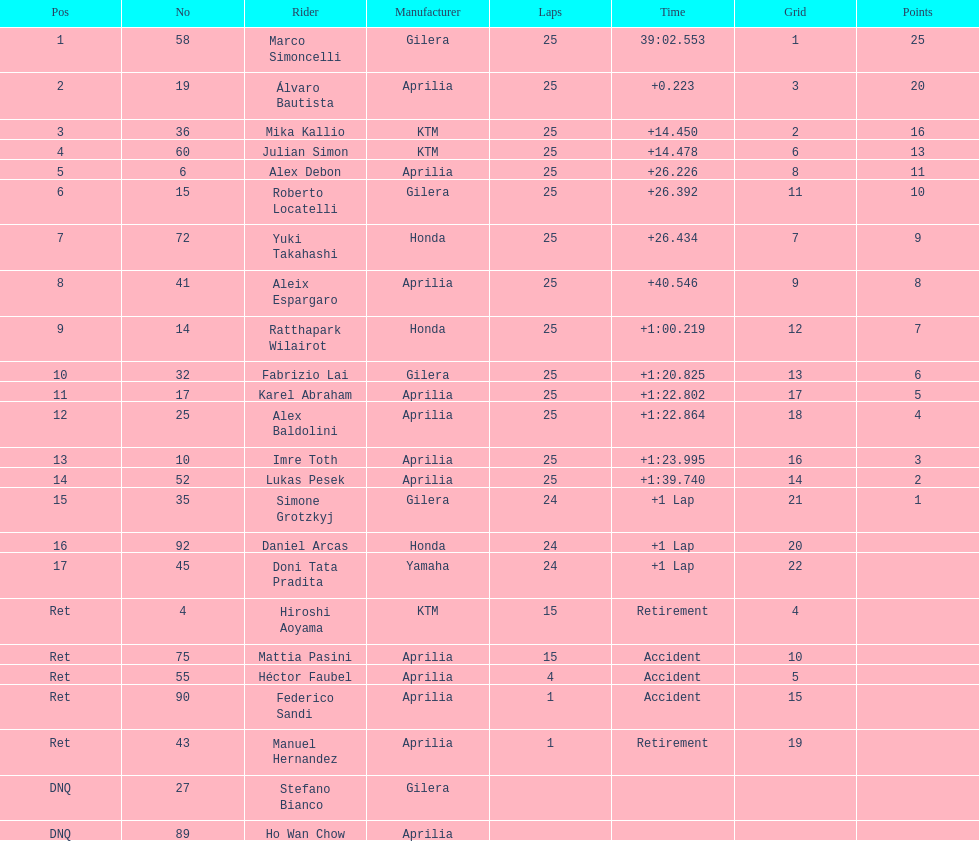Could you parse the entire table? {'header': ['Pos', 'No', 'Rider', 'Manufacturer', 'Laps', 'Time', 'Grid', 'Points'], 'rows': [['1', '58', 'Marco Simoncelli', 'Gilera', '25', '39:02.553', '1', '25'], ['2', '19', 'Álvaro Bautista', 'Aprilia', '25', '+0.223', '3', '20'], ['3', '36', 'Mika Kallio', 'KTM', '25', '+14.450', '2', '16'], ['4', '60', 'Julian Simon', 'KTM', '25', '+14.478', '6', '13'], ['5', '6', 'Alex Debon', 'Aprilia', '25', '+26.226', '8', '11'], ['6', '15', 'Roberto Locatelli', 'Gilera', '25', '+26.392', '11', '10'], ['7', '72', 'Yuki Takahashi', 'Honda', '25', '+26.434', '7', '9'], ['8', '41', 'Aleix Espargaro', 'Aprilia', '25', '+40.546', '9', '8'], ['9', '14', 'Ratthapark Wilairot', 'Honda', '25', '+1:00.219', '12', '7'], ['10', '32', 'Fabrizio Lai', 'Gilera', '25', '+1:20.825', '13', '6'], ['11', '17', 'Karel Abraham', 'Aprilia', '25', '+1:22.802', '17', '5'], ['12', '25', 'Alex Baldolini', 'Aprilia', '25', '+1:22.864', '18', '4'], ['13', '10', 'Imre Toth', 'Aprilia', '25', '+1:23.995', '16', '3'], ['14', '52', 'Lukas Pesek', 'Aprilia', '25', '+1:39.740', '14', '2'], ['15', '35', 'Simone Grotzkyj', 'Gilera', '24', '+1 Lap', '21', '1'], ['16', '92', 'Daniel Arcas', 'Honda', '24', '+1 Lap', '20', ''], ['17', '45', 'Doni Tata Pradita', 'Yamaha', '24', '+1 Lap', '22', ''], ['Ret', '4', 'Hiroshi Aoyama', 'KTM', '15', 'Retirement', '4', ''], ['Ret', '75', 'Mattia Pasini', 'Aprilia', '15', 'Accident', '10', ''], ['Ret', '55', 'Héctor Faubel', 'Aprilia', '4', 'Accident', '5', ''], ['Ret', '90', 'Federico Sandi', 'Aprilia', '1', 'Accident', '15', ''], ['Ret', '43', 'Manuel Hernandez', 'Aprilia', '1', 'Retirement', '19', ''], ['DNQ', '27', 'Stefano Bianco', 'Gilera', '', '', '', ''], ['DNQ', '89', 'Ho Wan Chow', 'Aprilia', '', '', '', '']]} Did marco simoncelli or alvaro bautista held rank 1? Marco Simoncelli. 